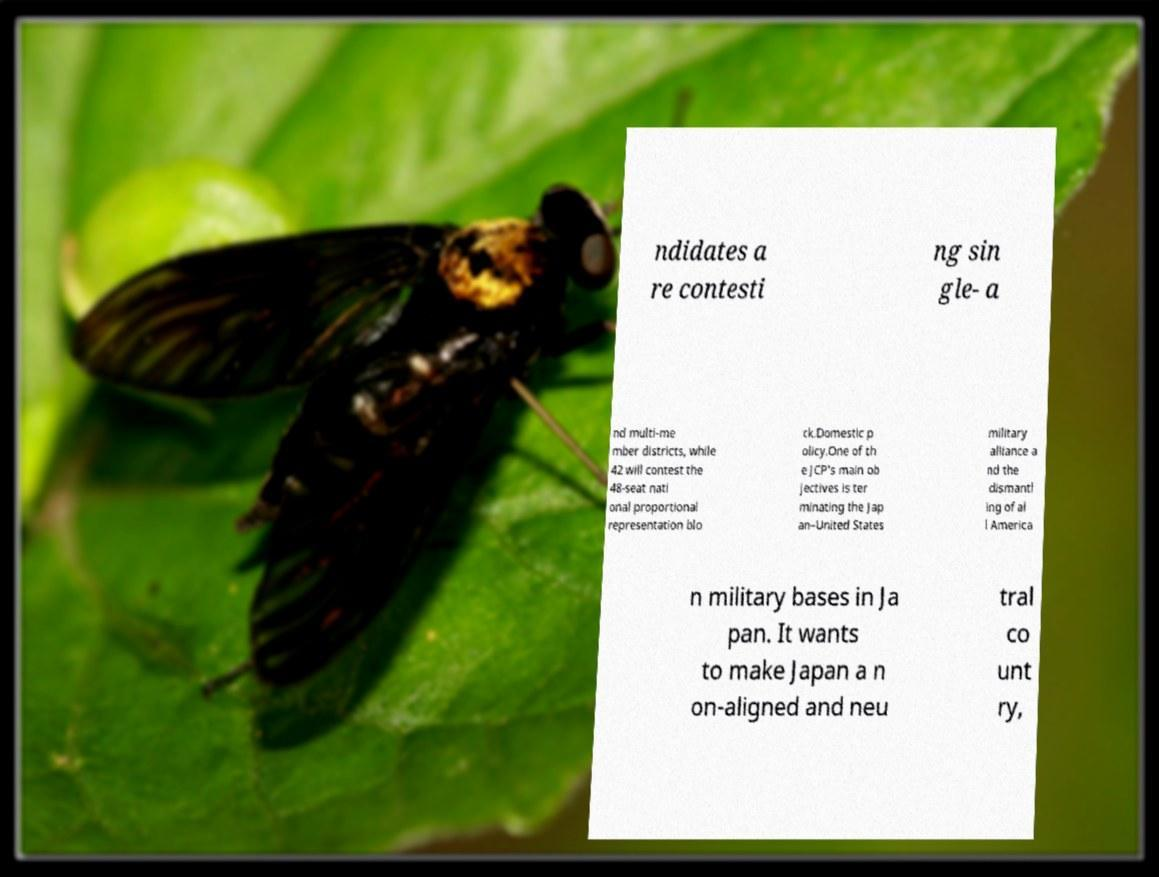There's text embedded in this image that I need extracted. Can you transcribe it verbatim? ndidates a re contesti ng sin gle- a nd multi-me mber districts, while 42 will contest the 48-seat nati onal proportional representation blo ck.Domestic p olicy.One of th e JCP's main ob jectives is ter minating the Jap an–United States military alliance a nd the dismantl ing of al l America n military bases in Ja pan. It wants to make Japan a n on-aligned and neu tral co unt ry, 